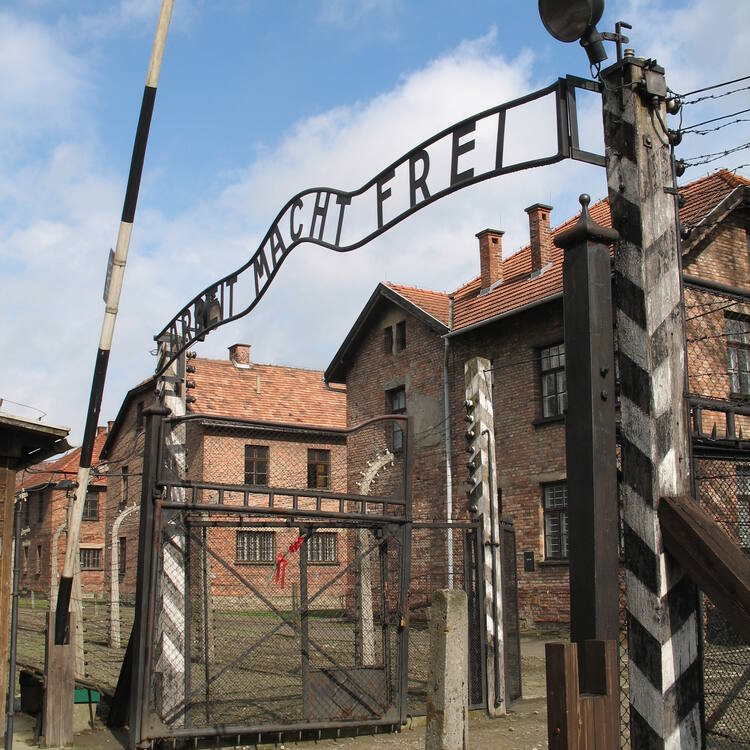If the camp’s gate could speak, what story would it tell? If the camp’s gate could speak, it would tell a harrowing story of untold suffering and the indomitable human spirit. It would describe the countless individuals who passed beneath its arch, each carrying the weight of hopelessness and fear. The gate would recall the daily influx of prisoners, the heart-wrenching separations of families, and the relentless march towards uncertain fates. It would speak of the cruel deception of its inscription, promising freedom through work, while instead leading to unimaginable hardship and death. However, amidst the tales of horror, the gate would also tell of moments of resistance, solidarity, and the unwavering will to live. It would narrate the resilience shown by the prisoners, the whispers of hope exchanged in the dead of night, and small acts of defiance against the looming oppression. 